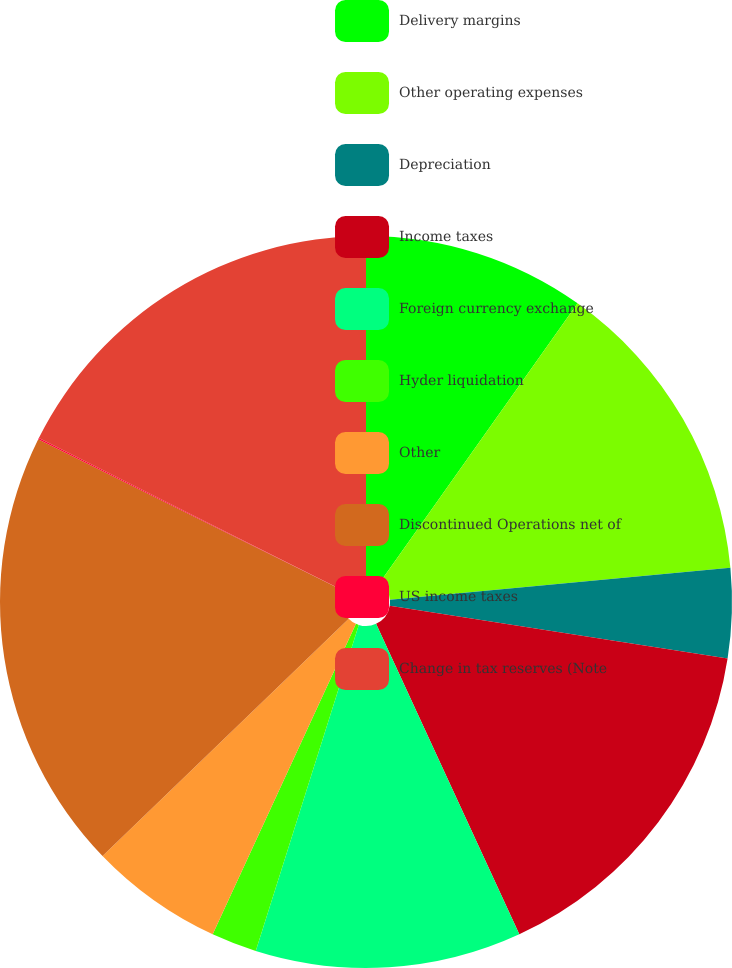Convert chart. <chart><loc_0><loc_0><loc_500><loc_500><pie_chart><fcel>Delivery margins<fcel>Other operating expenses<fcel>Depreciation<fcel>Income taxes<fcel>Foreign currency exchange<fcel>Hyder liquidation<fcel>Other<fcel>Discontinued Operations net of<fcel>US income taxes<fcel>Change in tax reserves (Note<nl><fcel>9.81%<fcel>13.7%<fcel>3.96%<fcel>15.65%<fcel>11.75%<fcel>2.01%<fcel>5.91%<fcel>19.55%<fcel>0.06%<fcel>17.6%<nl></chart> 